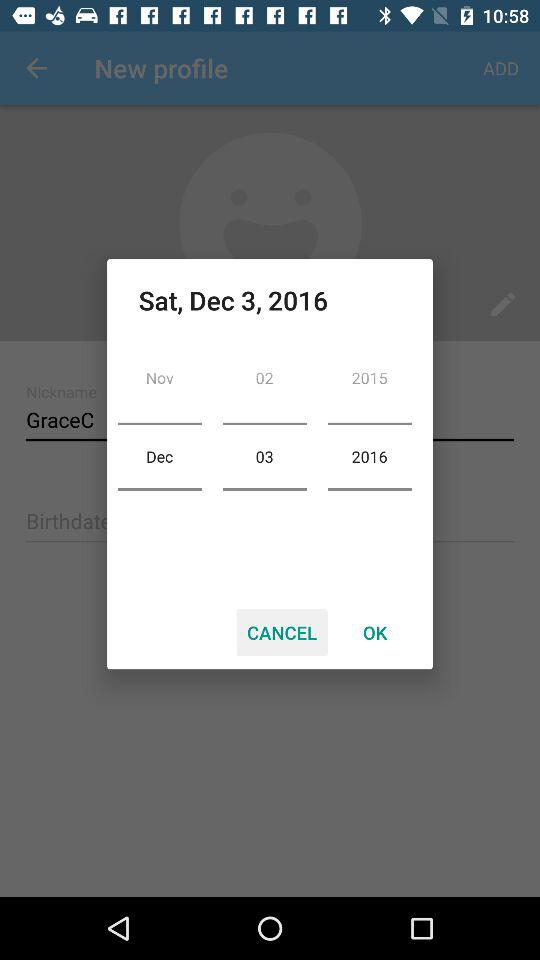Which is the selected date? The selected date is Saturday, December 3, 2016. 